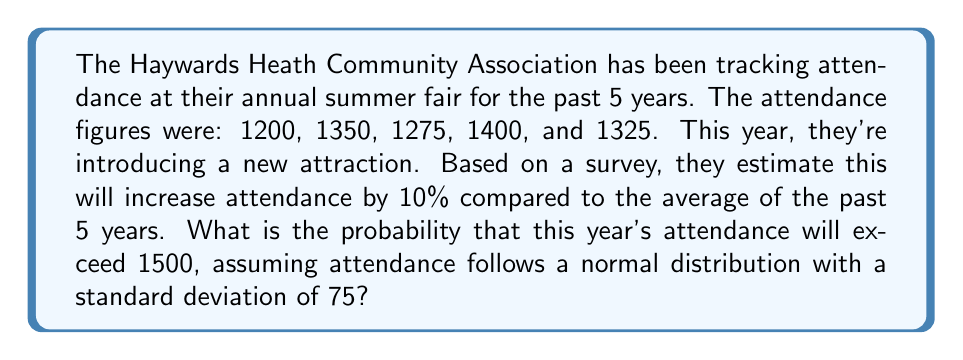Show me your answer to this math problem. Let's approach this step-by-step:

1) First, calculate the mean attendance for the past 5 years:
   $$ \mu = \frac{1200 + 1350 + 1275 + 1400 + 1325}{5} = 1310 $$

2) With the new attraction, the expected attendance this year is:
   $$ \text{Expected Attendance} = 1310 \times 1.10 = 1441 $$

3) We're given that the standard deviation $\sigma = 75$.

4) To exceed 1500, we need to calculate:
   $$ P(X > 1500) $$
   where X is the attendance this year.

5) Standardize the variable:
   $$ Z = \frac{X - \mu}{\sigma} = \frac{1500 - 1441}{75} = 0.7867 $$

6) We need to find $P(Z > 0.7867)$

7) Using a standard normal table or calculator:
   $$ P(Z > 0.7867) = 1 - P(Z < 0.7867) = 1 - 0.7842 = 0.2158 $$

Therefore, the probability that this year's attendance will exceed 1500 is approximately 0.2158 or 21.58%.
Answer: 0.2158 